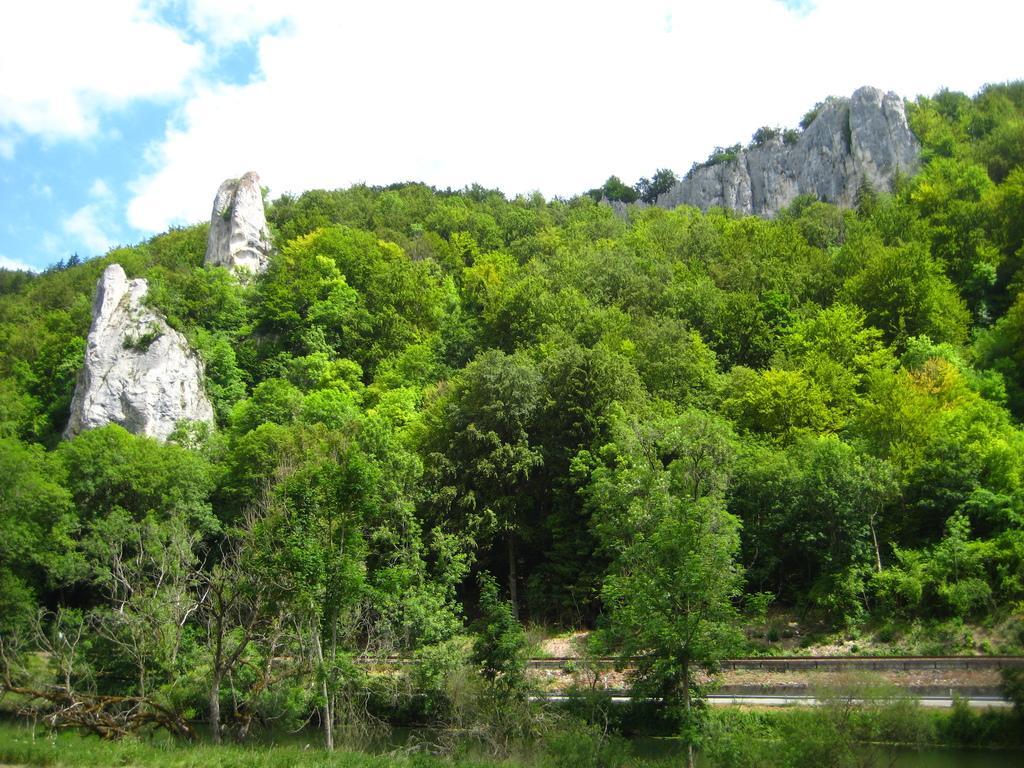In one or two sentences, can you explain what this image depicts? In this picture we can see trees and rocks, in the background we can see clouds. 